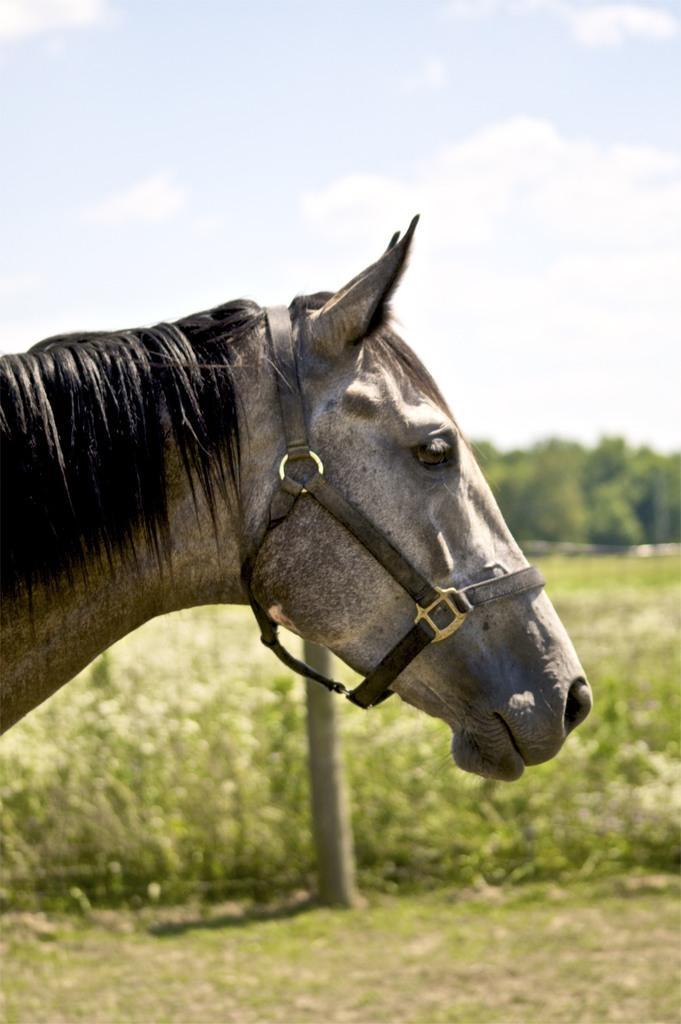What part of the horse is the focus of the image? There is a close view of a horse's neck in the image. What type of vegetation can be seen behind the horse? There are green plants visible behind the horse. What else is present in the background of the image? There are trees in the background of the image. What type of cave can be seen in the background of the image? There is no cave present in the image; it features a close view of a horse's neck with green plants and trees in the background. Can you see a town in the background of the image? There is no town visible in the image; it only shows a horse's neck, green plants, and trees in the background. 